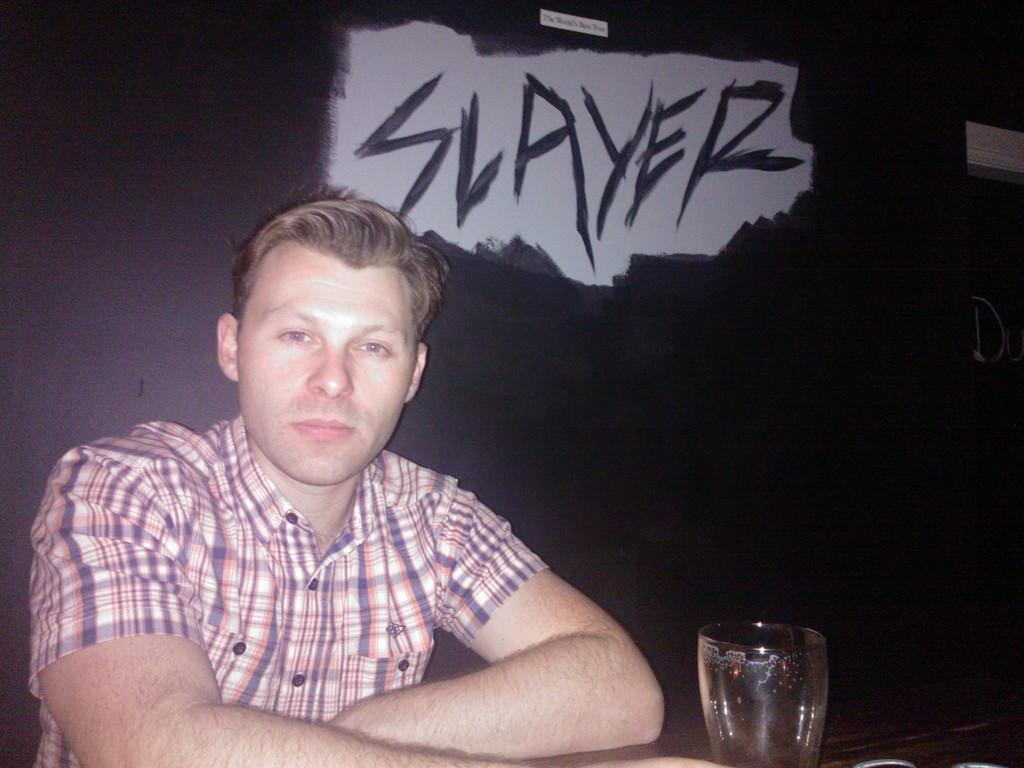Who is present in the image? There is a man in the image. What is the man doing in the image? The man is seated. What object is in front of the man? There is a glass in front of the man. What type of squirrel can be seen sitting next to the man in the image? There is no squirrel present in the image; only the man and a glass are visible. 